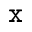Convert formula to latex. <formula><loc_0><loc_0><loc_500><loc_500>^ { x }</formula> 